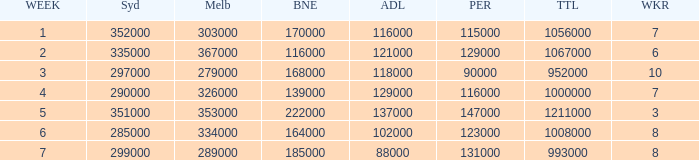How many Adelaide viewers were there in Week 5? 137000.0. Could you parse the entire table as a dict? {'header': ['WEEK', 'Syd', 'Melb', 'BNE', 'ADL', 'PER', 'TTL', 'WKR'], 'rows': [['1', '352000', '303000', '170000', '116000', '115000', '1056000', '7'], ['2', '335000', '367000', '116000', '121000', '129000', '1067000', '6'], ['3', '297000', '279000', '168000', '118000', '90000', '952000', '10'], ['4', '290000', '326000', '139000', '129000', '116000', '1000000', '7'], ['5', '351000', '353000', '222000', '137000', '147000', '1211000', '3'], ['6', '285000', '334000', '164000', '102000', '123000', '1008000', '8'], ['7', '299000', '289000', '185000', '88000', '131000', '993000', '8']]} 